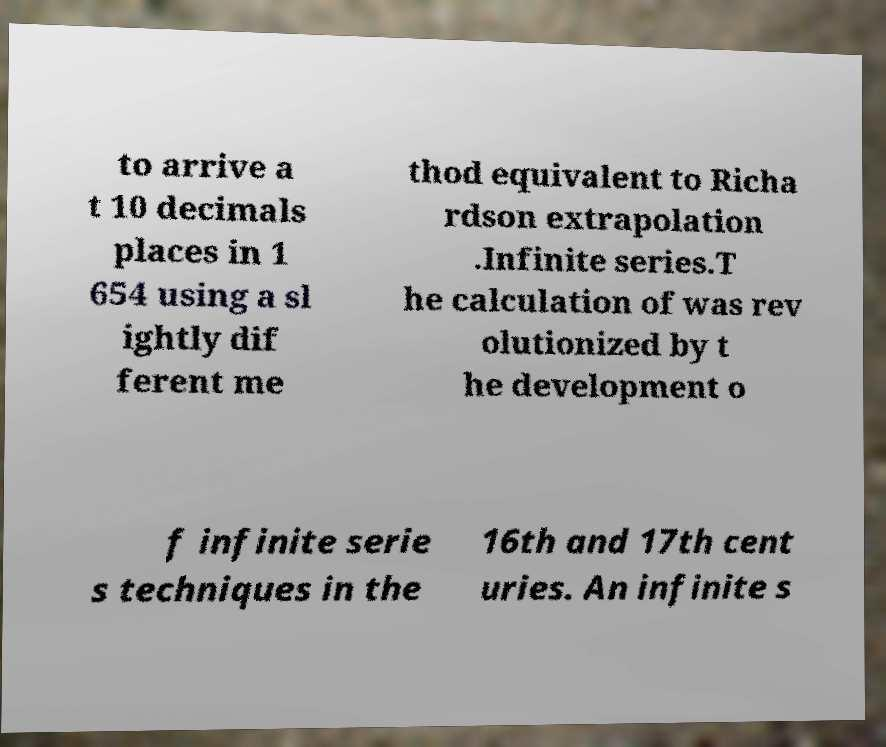Please identify and transcribe the text found in this image. to arrive a t 10 decimals places in 1 654 using a sl ightly dif ferent me thod equivalent to Richa rdson extrapolation .Infinite series.T he calculation of was rev olutionized by t he development o f infinite serie s techniques in the 16th and 17th cent uries. An infinite s 